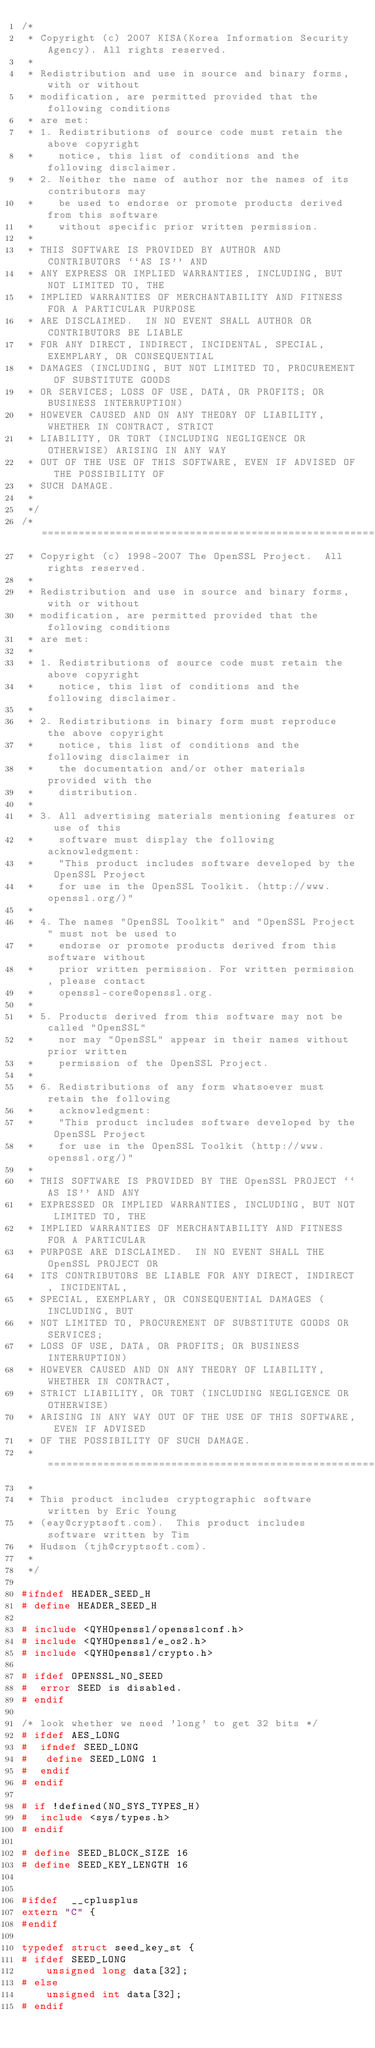Convert code to text. <code><loc_0><loc_0><loc_500><loc_500><_C_>/*
 * Copyright (c) 2007 KISA(Korea Information Security Agency). All rights reserved.
 *
 * Redistribution and use in source and binary forms, with or without
 * modification, are permitted provided that the following conditions
 * are met:
 * 1. Redistributions of source code must retain the above copyright
 *    notice, this list of conditions and the following disclaimer.
 * 2. Neither the name of author nor the names of its contributors may
 *    be used to endorse or promote products derived from this software
 *    without specific prior written permission.
 *
 * THIS SOFTWARE IS PROVIDED BY AUTHOR AND CONTRIBUTORS ``AS IS'' AND
 * ANY EXPRESS OR IMPLIED WARRANTIES, INCLUDING, BUT NOT LIMITED TO, THE
 * IMPLIED WARRANTIES OF MERCHANTABILITY AND FITNESS FOR A PARTICULAR PURPOSE
 * ARE DISCLAIMED.  IN NO EVENT SHALL AUTHOR OR CONTRIBUTORS BE LIABLE
 * FOR ANY DIRECT, INDIRECT, INCIDENTAL, SPECIAL, EXEMPLARY, OR CONSEQUENTIAL
 * DAMAGES (INCLUDING, BUT NOT LIMITED TO, PROCUREMENT OF SUBSTITUTE GOODS
 * OR SERVICES; LOSS OF USE, DATA, OR PROFITS; OR BUSINESS INTERRUPTION)
 * HOWEVER CAUSED AND ON ANY THEORY OF LIABILITY, WHETHER IN CONTRACT, STRICT
 * LIABILITY, OR TORT (INCLUDING NEGLIGENCE OR OTHERWISE) ARISING IN ANY WAY
 * OUT OF THE USE OF THIS SOFTWARE, EVEN IF ADVISED OF THE POSSIBILITY OF
 * SUCH DAMAGE.
 *
 */
/* ====================================================================
 * Copyright (c) 1998-2007 The OpenSSL Project.  All rights reserved.
 *
 * Redistribution and use in source and binary forms, with or without
 * modification, are permitted provided that the following conditions
 * are met:
 *
 * 1. Redistributions of source code must retain the above copyright
 *    notice, this list of conditions and the following disclaimer.
 *
 * 2. Redistributions in binary form must reproduce the above copyright
 *    notice, this list of conditions and the following disclaimer in
 *    the documentation and/or other materials provided with the
 *    distribution.
 *
 * 3. All advertising materials mentioning features or use of this
 *    software must display the following acknowledgment:
 *    "This product includes software developed by the OpenSSL Project
 *    for use in the OpenSSL Toolkit. (http://www.openssl.org/)"
 *
 * 4. The names "OpenSSL Toolkit" and "OpenSSL Project" must not be used to
 *    endorse or promote products derived from this software without
 *    prior written permission. For written permission, please contact
 *    openssl-core@openssl.org.
 *
 * 5. Products derived from this software may not be called "OpenSSL"
 *    nor may "OpenSSL" appear in their names without prior written
 *    permission of the OpenSSL Project.
 *
 * 6. Redistributions of any form whatsoever must retain the following
 *    acknowledgment:
 *    "This product includes software developed by the OpenSSL Project
 *    for use in the OpenSSL Toolkit (http://www.openssl.org/)"
 *
 * THIS SOFTWARE IS PROVIDED BY THE OpenSSL PROJECT ``AS IS'' AND ANY
 * EXPRESSED OR IMPLIED WARRANTIES, INCLUDING, BUT NOT LIMITED TO, THE
 * IMPLIED WARRANTIES OF MERCHANTABILITY AND FITNESS FOR A PARTICULAR
 * PURPOSE ARE DISCLAIMED.  IN NO EVENT SHALL THE OpenSSL PROJECT OR
 * ITS CONTRIBUTORS BE LIABLE FOR ANY DIRECT, INDIRECT, INCIDENTAL,
 * SPECIAL, EXEMPLARY, OR CONSEQUENTIAL DAMAGES (INCLUDING, BUT
 * NOT LIMITED TO, PROCUREMENT OF SUBSTITUTE GOODS OR SERVICES;
 * LOSS OF USE, DATA, OR PROFITS; OR BUSINESS INTERRUPTION)
 * HOWEVER CAUSED AND ON ANY THEORY OF LIABILITY, WHETHER IN CONTRACT,
 * STRICT LIABILITY, OR TORT (INCLUDING NEGLIGENCE OR OTHERWISE)
 * ARISING IN ANY WAY OUT OF THE USE OF THIS SOFTWARE, EVEN IF ADVISED
 * OF THE POSSIBILITY OF SUCH DAMAGE.
 * ====================================================================
 *
 * This product includes cryptographic software written by Eric Young
 * (eay@cryptsoft.com).  This product includes software written by Tim
 * Hudson (tjh@cryptsoft.com).
 *
 */

#ifndef HEADER_SEED_H
# define HEADER_SEED_H

# include <QYHOpenssl/opensslconf.h>
# include <QYHOpenssl/e_os2.h>
# include <QYHOpenssl/crypto.h>

# ifdef OPENSSL_NO_SEED
#  error SEED is disabled.
# endif

/* look whether we need 'long' to get 32 bits */
# ifdef AES_LONG
#  ifndef SEED_LONG
#   define SEED_LONG 1
#  endif
# endif

# if !defined(NO_SYS_TYPES_H)
#  include <sys/types.h>
# endif

# define SEED_BLOCK_SIZE 16
# define SEED_KEY_LENGTH 16


#ifdef  __cplusplus
extern "C" {
#endif

typedef struct seed_key_st {
# ifdef SEED_LONG
    unsigned long data[32];
# else
    unsigned int data[32];
# endif</code> 